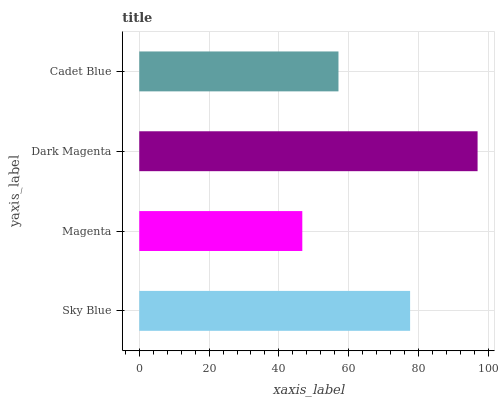Is Magenta the minimum?
Answer yes or no. Yes. Is Dark Magenta the maximum?
Answer yes or no. Yes. Is Dark Magenta the minimum?
Answer yes or no. No. Is Magenta the maximum?
Answer yes or no. No. Is Dark Magenta greater than Magenta?
Answer yes or no. Yes. Is Magenta less than Dark Magenta?
Answer yes or no. Yes. Is Magenta greater than Dark Magenta?
Answer yes or no. No. Is Dark Magenta less than Magenta?
Answer yes or no. No. Is Sky Blue the high median?
Answer yes or no. Yes. Is Cadet Blue the low median?
Answer yes or no. Yes. Is Dark Magenta the high median?
Answer yes or no. No. Is Magenta the low median?
Answer yes or no. No. 